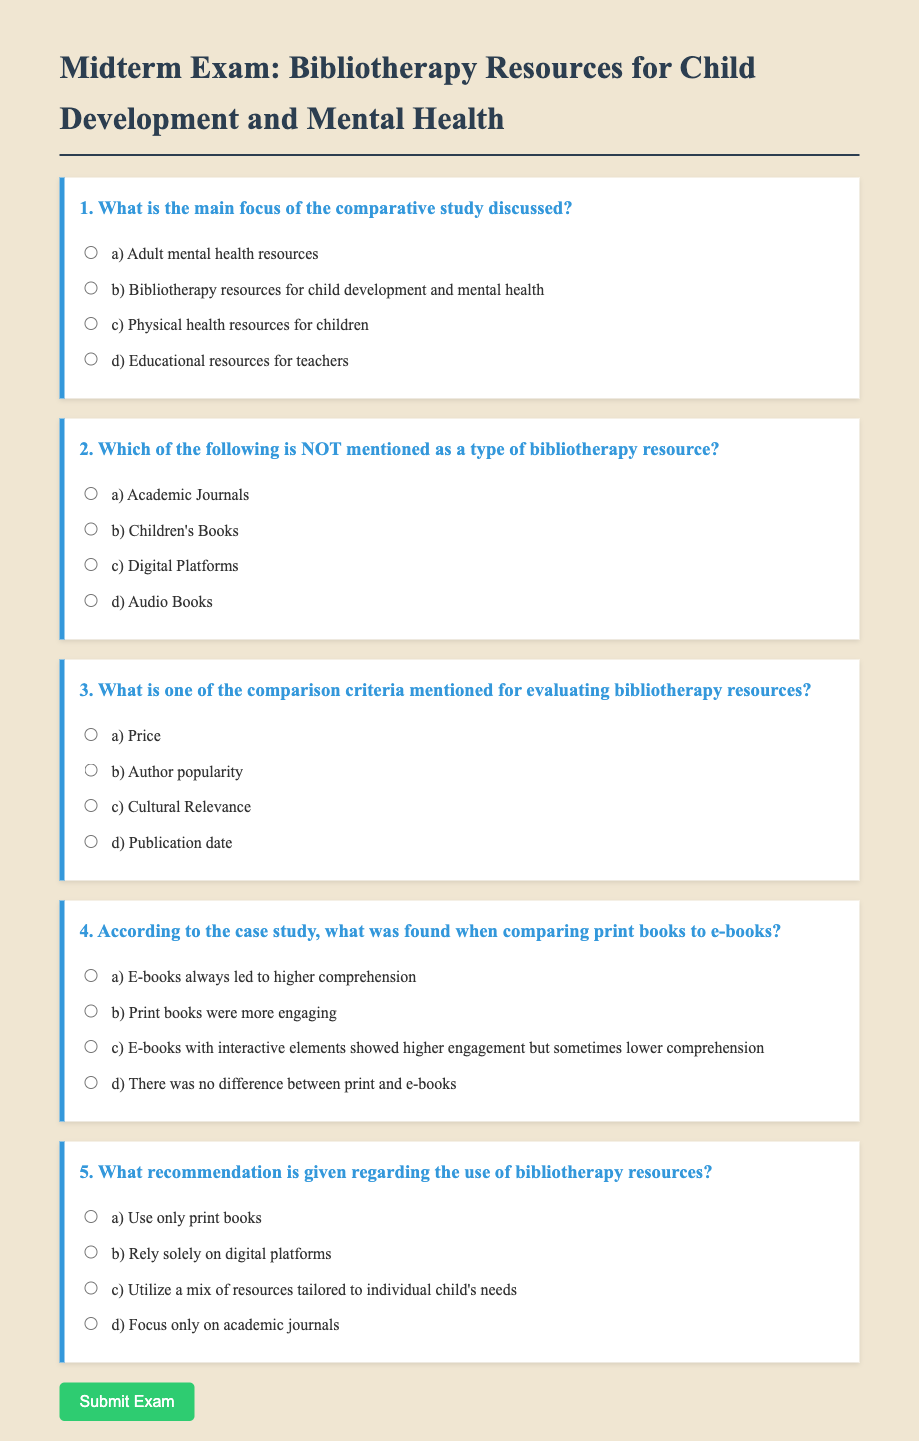What is the main focus of the study? The main focus is about bibliotherapy resources specifically designed for child development and mental health.
Answer: bibliotherapy resources for child development and mental health Which resource type is NOT mentioned? The question asks to identify the resource type that is absent in the study. Academic Journals is not listed as a bibliotherapy resource.
Answer: Academic Journals What is one comparison criterion for bibliotherapy resources? The document mentions cultural relevance as one of the criteria for evaluation.
Answer: Cultural Relevance What was found when comparing print books to e-books? The findings indicate that e-books with interactive elements can show high engagement but sometimes lower comprehension compared to print books.
Answer: E-books with interactive elements showed higher engagement but sometimes lower comprehension What is the recommendation regarding bibliotherapy resources? The recommendation suggests a mixed approach to utilizing bibliotherapy resources tailored to an individual child's needs.
Answer: Utilize a mix of resources tailored to individual child's needs 